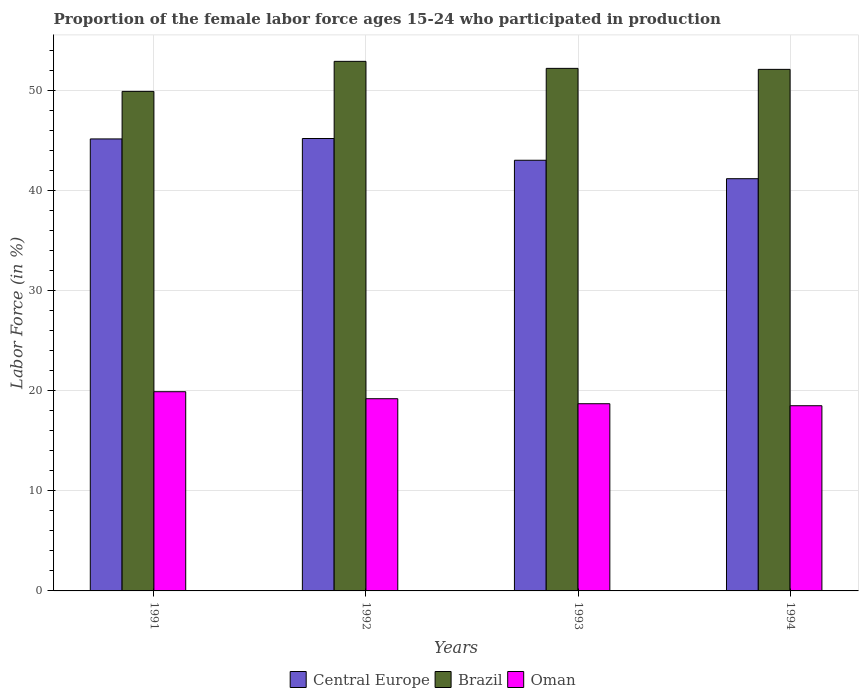How many different coloured bars are there?
Your response must be concise. 3. Are the number of bars on each tick of the X-axis equal?
Make the answer very short. Yes. In how many cases, is the number of bars for a given year not equal to the number of legend labels?
Give a very brief answer. 0. What is the proportion of the female labor force who participated in production in Oman in 1994?
Your answer should be compact. 18.5. Across all years, what is the maximum proportion of the female labor force who participated in production in Oman?
Offer a very short reply. 19.9. In which year was the proportion of the female labor force who participated in production in Central Europe maximum?
Ensure brevity in your answer.  1992. What is the total proportion of the female labor force who participated in production in Oman in the graph?
Your response must be concise. 76.3. What is the difference between the proportion of the female labor force who participated in production in Brazil in 1993 and that in 1994?
Your answer should be compact. 0.1. What is the difference between the proportion of the female labor force who participated in production in Oman in 1992 and the proportion of the female labor force who participated in production in Brazil in 1991?
Ensure brevity in your answer.  -30.7. What is the average proportion of the female labor force who participated in production in Central Europe per year?
Provide a succinct answer. 43.64. In the year 1992, what is the difference between the proportion of the female labor force who participated in production in Brazil and proportion of the female labor force who participated in production in Oman?
Offer a terse response. 33.7. In how many years, is the proportion of the female labor force who participated in production in Brazil greater than 16 %?
Give a very brief answer. 4. What is the ratio of the proportion of the female labor force who participated in production in Oman in 1991 to that in 1993?
Make the answer very short. 1.06. Is the difference between the proportion of the female labor force who participated in production in Brazil in 1992 and 1993 greater than the difference between the proportion of the female labor force who participated in production in Oman in 1992 and 1993?
Offer a terse response. Yes. What is the difference between the highest and the second highest proportion of the female labor force who participated in production in Brazil?
Keep it short and to the point. 0.7. Is the sum of the proportion of the female labor force who participated in production in Brazil in 1991 and 1993 greater than the maximum proportion of the female labor force who participated in production in Oman across all years?
Give a very brief answer. Yes. What does the 2nd bar from the left in 1993 represents?
Provide a short and direct response. Brazil. What does the 2nd bar from the right in 1994 represents?
Provide a succinct answer. Brazil. How many bars are there?
Offer a terse response. 12. Are all the bars in the graph horizontal?
Keep it short and to the point. No. What is the difference between two consecutive major ticks on the Y-axis?
Offer a terse response. 10. Are the values on the major ticks of Y-axis written in scientific E-notation?
Offer a very short reply. No. Does the graph contain any zero values?
Make the answer very short. No. Does the graph contain grids?
Your answer should be compact. Yes. Where does the legend appear in the graph?
Provide a succinct answer. Bottom center. How are the legend labels stacked?
Keep it short and to the point. Horizontal. What is the title of the graph?
Ensure brevity in your answer.  Proportion of the female labor force ages 15-24 who participated in production. Does "Isle of Man" appear as one of the legend labels in the graph?
Your answer should be very brief. No. What is the label or title of the Y-axis?
Your response must be concise. Labor Force (in %). What is the Labor Force (in %) in Central Europe in 1991?
Keep it short and to the point. 45.15. What is the Labor Force (in %) in Brazil in 1991?
Make the answer very short. 49.9. What is the Labor Force (in %) of Oman in 1991?
Make the answer very short. 19.9. What is the Labor Force (in %) of Central Europe in 1992?
Give a very brief answer. 45.19. What is the Labor Force (in %) in Brazil in 1992?
Keep it short and to the point. 52.9. What is the Labor Force (in %) in Oman in 1992?
Your answer should be compact. 19.2. What is the Labor Force (in %) in Central Europe in 1993?
Offer a terse response. 43.02. What is the Labor Force (in %) of Brazil in 1993?
Ensure brevity in your answer.  52.2. What is the Labor Force (in %) in Oman in 1993?
Your answer should be very brief. 18.7. What is the Labor Force (in %) in Central Europe in 1994?
Your answer should be very brief. 41.18. What is the Labor Force (in %) in Brazil in 1994?
Ensure brevity in your answer.  52.1. What is the Labor Force (in %) of Oman in 1994?
Your answer should be compact. 18.5. Across all years, what is the maximum Labor Force (in %) of Central Europe?
Provide a succinct answer. 45.19. Across all years, what is the maximum Labor Force (in %) in Brazil?
Provide a succinct answer. 52.9. Across all years, what is the maximum Labor Force (in %) in Oman?
Your answer should be very brief. 19.9. Across all years, what is the minimum Labor Force (in %) of Central Europe?
Offer a terse response. 41.18. Across all years, what is the minimum Labor Force (in %) in Brazil?
Offer a terse response. 49.9. What is the total Labor Force (in %) in Central Europe in the graph?
Your answer should be very brief. 174.54. What is the total Labor Force (in %) in Brazil in the graph?
Offer a very short reply. 207.1. What is the total Labor Force (in %) in Oman in the graph?
Offer a very short reply. 76.3. What is the difference between the Labor Force (in %) in Central Europe in 1991 and that in 1992?
Your answer should be compact. -0.04. What is the difference between the Labor Force (in %) in Oman in 1991 and that in 1992?
Offer a very short reply. 0.7. What is the difference between the Labor Force (in %) of Central Europe in 1991 and that in 1993?
Provide a succinct answer. 2.13. What is the difference between the Labor Force (in %) of Brazil in 1991 and that in 1993?
Your answer should be very brief. -2.3. What is the difference between the Labor Force (in %) of Oman in 1991 and that in 1993?
Offer a terse response. 1.2. What is the difference between the Labor Force (in %) in Central Europe in 1991 and that in 1994?
Offer a terse response. 3.97. What is the difference between the Labor Force (in %) in Brazil in 1991 and that in 1994?
Provide a short and direct response. -2.2. What is the difference between the Labor Force (in %) in Central Europe in 1992 and that in 1993?
Provide a succinct answer. 2.17. What is the difference between the Labor Force (in %) in Brazil in 1992 and that in 1993?
Your answer should be compact. 0.7. What is the difference between the Labor Force (in %) in Oman in 1992 and that in 1993?
Your answer should be compact. 0.5. What is the difference between the Labor Force (in %) in Central Europe in 1992 and that in 1994?
Keep it short and to the point. 4.02. What is the difference between the Labor Force (in %) of Brazil in 1992 and that in 1994?
Provide a short and direct response. 0.8. What is the difference between the Labor Force (in %) of Central Europe in 1993 and that in 1994?
Your answer should be compact. 1.84. What is the difference between the Labor Force (in %) in Brazil in 1993 and that in 1994?
Offer a very short reply. 0.1. What is the difference between the Labor Force (in %) in Oman in 1993 and that in 1994?
Ensure brevity in your answer.  0.2. What is the difference between the Labor Force (in %) of Central Europe in 1991 and the Labor Force (in %) of Brazil in 1992?
Your answer should be compact. -7.75. What is the difference between the Labor Force (in %) of Central Europe in 1991 and the Labor Force (in %) of Oman in 1992?
Your answer should be very brief. 25.95. What is the difference between the Labor Force (in %) of Brazil in 1991 and the Labor Force (in %) of Oman in 1992?
Your answer should be very brief. 30.7. What is the difference between the Labor Force (in %) in Central Europe in 1991 and the Labor Force (in %) in Brazil in 1993?
Provide a succinct answer. -7.05. What is the difference between the Labor Force (in %) of Central Europe in 1991 and the Labor Force (in %) of Oman in 1993?
Offer a terse response. 26.45. What is the difference between the Labor Force (in %) of Brazil in 1991 and the Labor Force (in %) of Oman in 1993?
Ensure brevity in your answer.  31.2. What is the difference between the Labor Force (in %) of Central Europe in 1991 and the Labor Force (in %) of Brazil in 1994?
Provide a short and direct response. -6.95. What is the difference between the Labor Force (in %) in Central Europe in 1991 and the Labor Force (in %) in Oman in 1994?
Provide a succinct answer. 26.65. What is the difference between the Labor Force (in %) of Brazil in 1991 and the Labor Force (in %) of Oman in 1994?
Your answer should be compact. 31.4. What is the difference between the Labor Force (in %) in Central Europe in 1992 and the Labor Force (in %) in Brazil in 1993?
Ensure brevity in your answer.  -7.01. What is the difference between the Labor Force (in %) in Central Europe in 1992 and the Labor Force (in %) in Oman in 1993?
Your answer should be compact. 26.49. What is the difference between the Labor Force (in %) in Brazil in 1992 and the Labor Force (in %) in Oman in 1993?
Make the answer very short. 34.2. What is the difference between the Labor Force (in %) of Central Europe in 1992 and the Labor Force (in %) of Brazil in 1994?
Offer a very short reply. -6.91. What is the difference between the Labor Force (in %) in Central Europe in 1992 and the Labor Force (in %) in Oman in 1994?
Keep it short and to the point. 26.69. What is the difference between the Labor Force (in %) in Brazil in 1992 and the Labor Force (in %) in Oman in 1994?
Give a very brief answer. 34.4. What is the difference between the Labor Force (in %) of Central Europe in 1993 and the Labor Force (in %) of Brazil in 1994?
Provide a short and direct response. -9.08. What is the difference between the Labor Force (in %) in Central Europe in 1993 and the Labor Force (in %) in Oman in 1994?
Make the answer very short. 24.52. What is the difference between the Labor Force (in %) of Brazil in 1993 and the Labor Force (in %) of Oman in 1994?
Keep it short and to the point. 33.7. What is the average Labor Force (in %) in Central Europe per year?
Your response must be concise. 43.64. What is the average Labor Force (in %) of Brazil per year?
Provide a short and direct response. 51.77. What is the average Labor Force (in %) in Oman per year?
Make the answer very short. 19.07. In the year 1991, what is the difference between the Labor Force (in %) of Central Europe and Labor Force (in %) of Brazil?
Your response must be concise. -4.75. In the year 1991, what is the difference between the Labor Force (in %) of Central Europe and Labor Force (in %) of Oman?
Give a very brief answer. 25.25. In the year 1991, what is the difference between the Labor Force (in %) of Brazil and Labor Force (in %) of Oman?
Provide a succinct answer. 30. In the year 1992, what is the difference between the Labor Force (in %) in Central Europe and Labor Force (in %) in Brazil?
Your response must be concise. -7.71. In the year 1992, what is the difference between the Labor Force (in %) of Central Europe and Labor Force (in %) of Oman?
Provide a succinct answer. 25.99. In the year 1992, what is the difference between the Labor Force (in %) in Brazil and Labor Force (in %) in Oman?
Ensure brevity in your answer.  33.7. In the year 1993, what is the difference between the Labor Force (in %) in Central Europe and Labor Force (in %) in Brazil?
Offer a terse response. -9.18. In the year 1993, what is the difference between the Labor Force (in %) of Central Europe and Labor Force (in %) of Oman?
Keep it short and to the point. 24.32. In the year 1993, what is the difference between the Labor Force (in %) in Brazil and Labor Force (in %) in Oman?
Give a very brief answer. 33.5. In the year 1994, what is the difference between the Labor Force (in %) of Central Europe and Labor Force (in %) of Brazil?
Your answer should be compact. -10.92. In the year 1994, what is the difference between the Labor Force (in %) of Central Europe and Labor Force (in %) of Oman?
Provide a short and direct response. 22.68. In the year 1994, what is the difference between the Labor Force (in %) of Brazil and Labor Force (in %) of Oman?
Provide a succinct answer. 33.6. What is the ratio of the Labor Force (in %) in Brazil in 1991 to that in 1992?
Provide a short and direct response. 0.94. What is the ratio of the Labor Force (in %) of Oman in 1991 to that in 1992?
Your answer should be very brief. 1.04. What is the ratio of the Labor Force (in %) in Central Europe in 1991 to that in 1993?
Make the answer very short. 1.05. What is the ratio of the Labor Force (in %) in Brazil in 1991 to that in 1993?
Keep it short and to the point. 0.96. What is the ratio of the Labor Force (in %) in Oman in 1991 to that in 1993?
Provide a short and direct response. 1.06. What is the ratio of the Labor Force (in %) in Central Europe in 1991 to that in 1994?
Make the answer very short. 1.1. What is the ratio of the Labor Force (in %) in Brazil in 1991 to that in 1994?
Keep it short and to the point. 0.96. What is the ratio of the Labor Force (in %) in Oman in 1991 to that in 1994?
Provide a succinct answer. 1.08. What is the ratio of the Labor Force (in %) in Central Europe in 1992 to that in 1993?
Provide a short and direct response. 1.05. What is the ratio of the Labor Force (in %) of Brazil in 1992 to that in 1993?
Your answer should be compact. 1.01. What is the ratio of the Labor Force (in %) in Oman in 1992 to that in 1993?
Offer a terse response. 1.03. What is the ratio of the Labor Force (in %) in Central Europe in 1992 to that in 1994?
Keep it short and to the point. 1.1. What is the ratio of the Labor Force (in %) of Brazil in 1992 to that in 1994?
Your answer should be compact. 1.02. What is the ratio of the Labor Force (in %) in Oman in 1992 to that in 1994?
Your response must be concise. 1.04. What is the ratio of the Labor Force (in %) of Central Europe in 1993 to that in 1994?
Give a very brief answer. 1.04. What is the ratio of the Labor Force (in %) of Brazil in 1993 to that in 1994?
Offer a terse response. 1. What is the ratio of the Labor Force (in %) of Oman in 1993 to that in 1994?
Offer a terse response. 1.01. What is the difference between the highest and the second highest Labor Force (in %) of Central Europe?
Your answer should be compact. 0.04. What is the difference between the highest and the second highest Labor Force (in %) in Brazil?
Make the answer very short. 0.7. What is the difference between the highest and the second highest Labor Force (in %) of Oman?
Your answer should be compact. 0.7. What is the difference between the highest and the lowest Labor Force (in %) of Central Europe?
Your answer should be compact. 4.02. What is the difference between the highest and the lowest Labor Force (in %) of Brazil?
Offer a terse response. 3. What is the difference between the highest and the lowest Labor Force (in %) in Oman?
Provide a succinct answer. 1.4. 